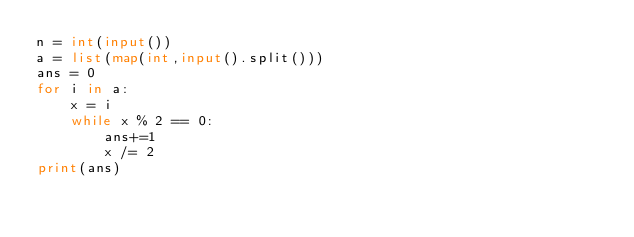Convert code to text. <code><loc_0><loc_0><loc_500><loc_500><_Python_>n = int(input())
a = list(map(int,input().split()))
ans = 0
for i in a:
    x = i
    while x % 2 == 0:
        ans+=1
        x /= 2
print(ans)</code> 